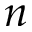<formula> <loc_0><loc_0><loc_500><loc_500>n</formula> 